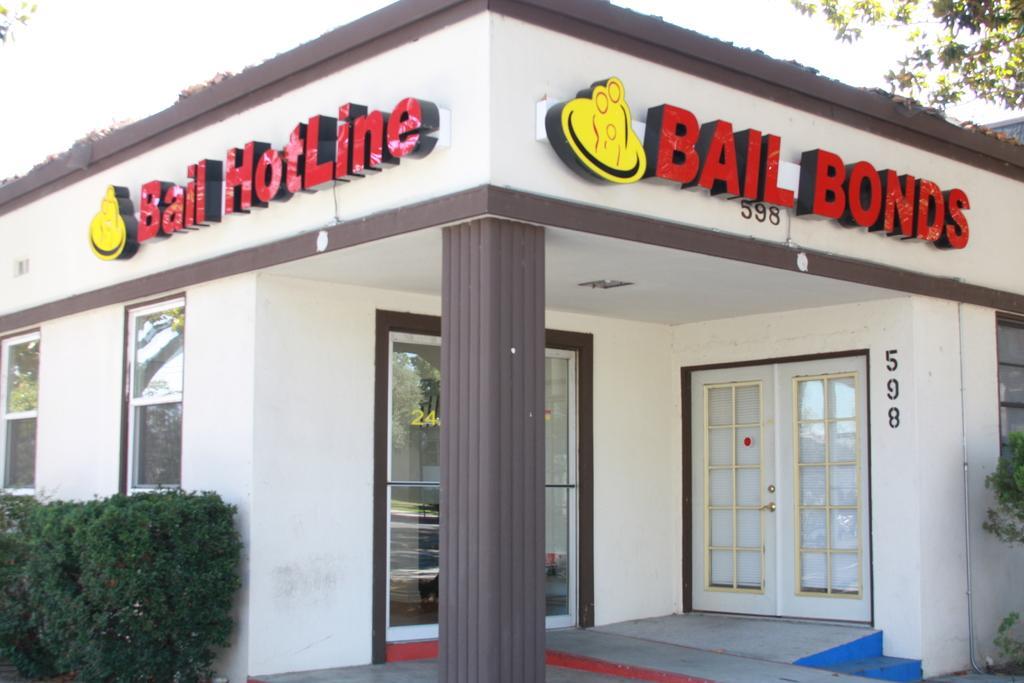Describe this image in one or two sentences. In this image in the front there is a building and on the top of the building. There are some text written on it. On the left side there are plants and on the right side there are leaves. 